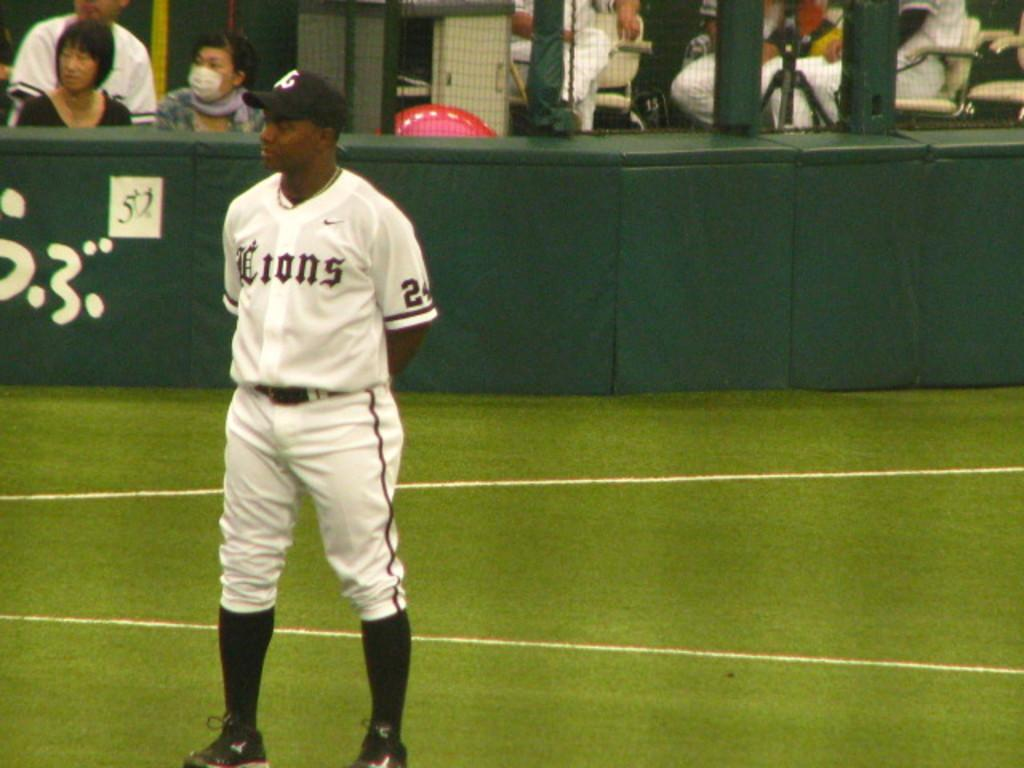<image>
Write a terse but informative summary of the picture. A player for the Lions stands on the field. 